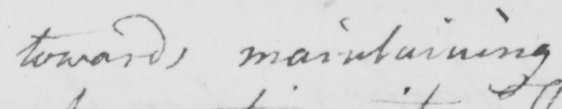Transcribe the text shown in this historical manuscript line. toward maintaining 